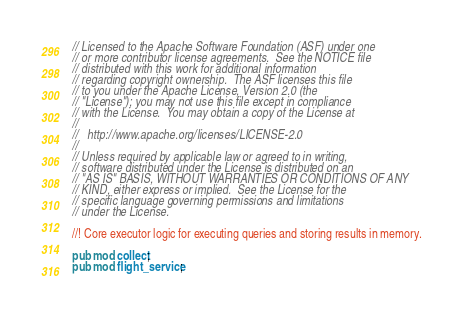Convert code to text. <code><loc_0><loc_0><loc_500><loc_500><_Rust_>// Licensed to the Apache Software Foundation (ASF) under one
// or more contributor license agreements.  See the NOTICE file
// distributed with this work for additional information
// regarding copyright ownership.  The ASF licenses this file
// to you under the Apache License, Version 2.0 (the
// "License"); you may not use this file except in compliance
// with the License.  You may obtain a copy of the License at
//
//   http://www.apache.org/licenses/LICENSE-2.0
//
// Unless required by applicable law or agreed to in writing,
// software distributed under the License is distributed on an
// "AS IS" BASIS, WITHOUT WARRANTIES OR CONDITIONS OF ANY
// KIND, either express or implied.  See the License for the
// specific language governing permissions and limitations
// under the License.

//! Core executor logic for executing queries and storing results in memory.

pub mod collect;
pub mod flight_service;
</code> 